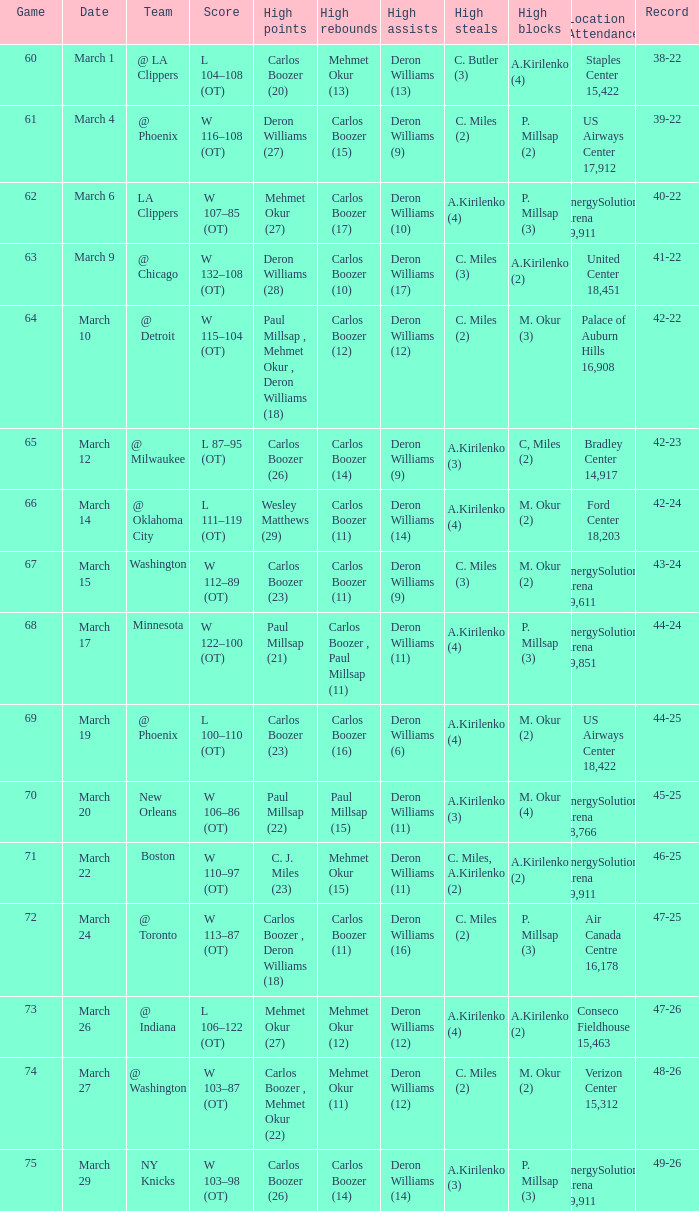How many different players did the most high assists on the March 4 game? 1.0. 